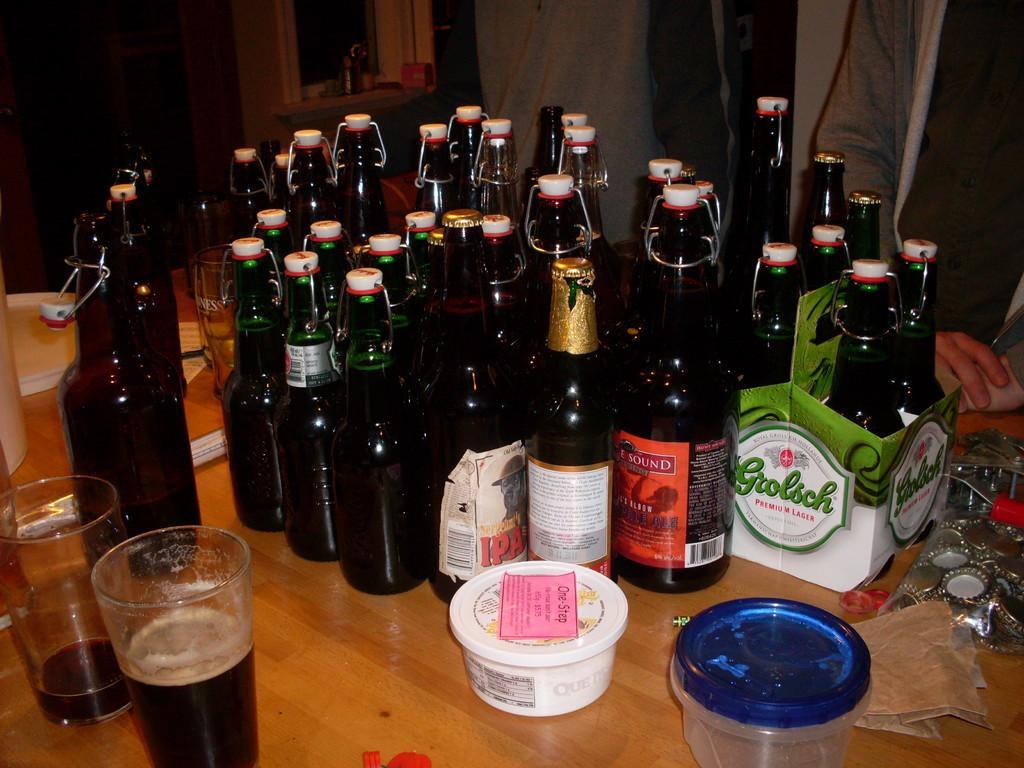Could you give a brief overview of what you see in this image? These are the beer bottles which are sealed with a cockpit and these are the tumblers with wine or alcohol in it. This is a white boxes. I can see a person standing here. This is a table. These are the metal caps which are placed on the table. At background this looks like a window. 